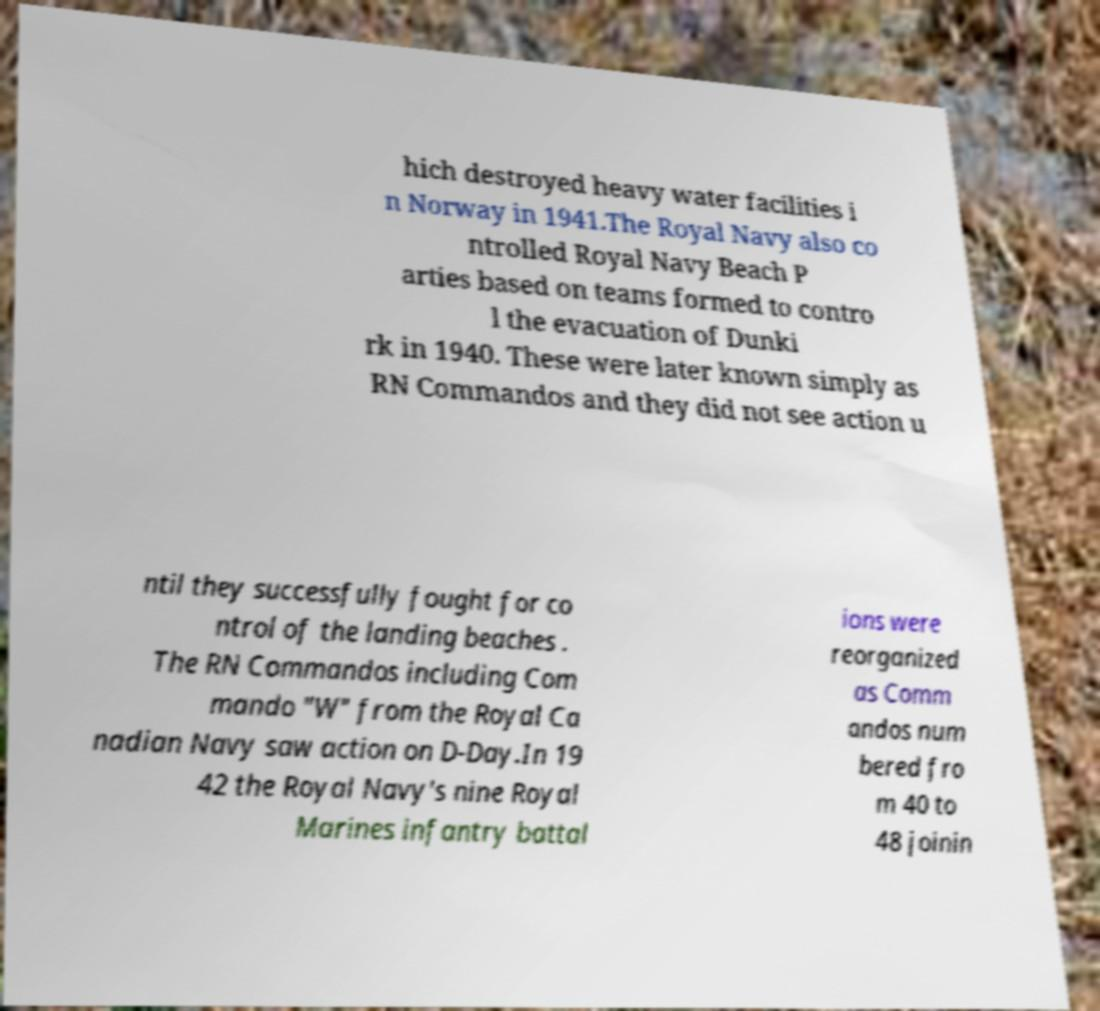I need the written content from this picture converted into text. Can you do that? hich destroyed heavy water facilities i n Norway in 1941.The Royal Navy also co ntrolled Royal Navy Beach P arties based on teams formed to contro l the evacuation of Dunki rk in 1940. These were later known simply as RN Commandos and they did not see action u ntil they successfully fought for co ntrol of the landing beaches . The RN Commandos including Com mando "W" from the Royal Ca nadian Navy saw action on D-Day.In 19 42 the Royal Navy's nine Royal Marines infantry battal ions were reorganized as Comm andos num bered fro m 40 to 48 joinin 